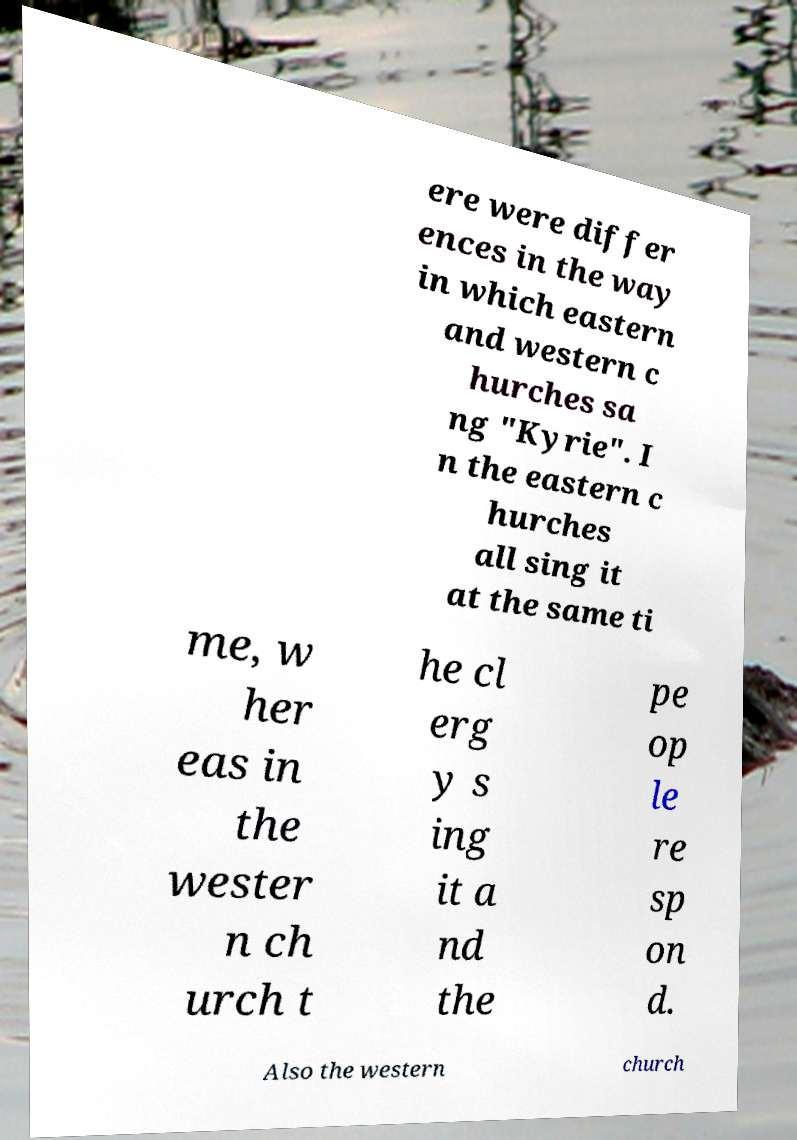There's text embedded in this image that I need extracted. Can you transcribe it verbatim? ere were differ ences in the way in which eastern and western c hurches sa ng "Kyrie". I n the eastern c hurches all sing it at the same ti me, w her eas in the wester n ch urch t he cl erg y s ing it a nd the pe op le re sp on d. Also the western church 